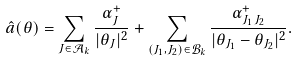Convert formula to latex. <formula><loc_0><loc_0><loc_500><loc_500>\hat { a } ( \theta ) = \sum _ { J \in { \mathcal { A } } _ { k } } \frac { \alpha _ { J } ^ { + } } { | \theta _ { J } | ^ { 2 } } + \sum _ { ( J _ { 1 } , J _ { 2 } ) \in \mathcal { B } _ { k } } \frac { \alpha _ { J _ { 1 } \, J _ { 2 } } ^ { + } } { | \theta _ { J _ { 1 } } - \theta _ { J _ { 2 } } | ^ { 2 } } .</formula> 